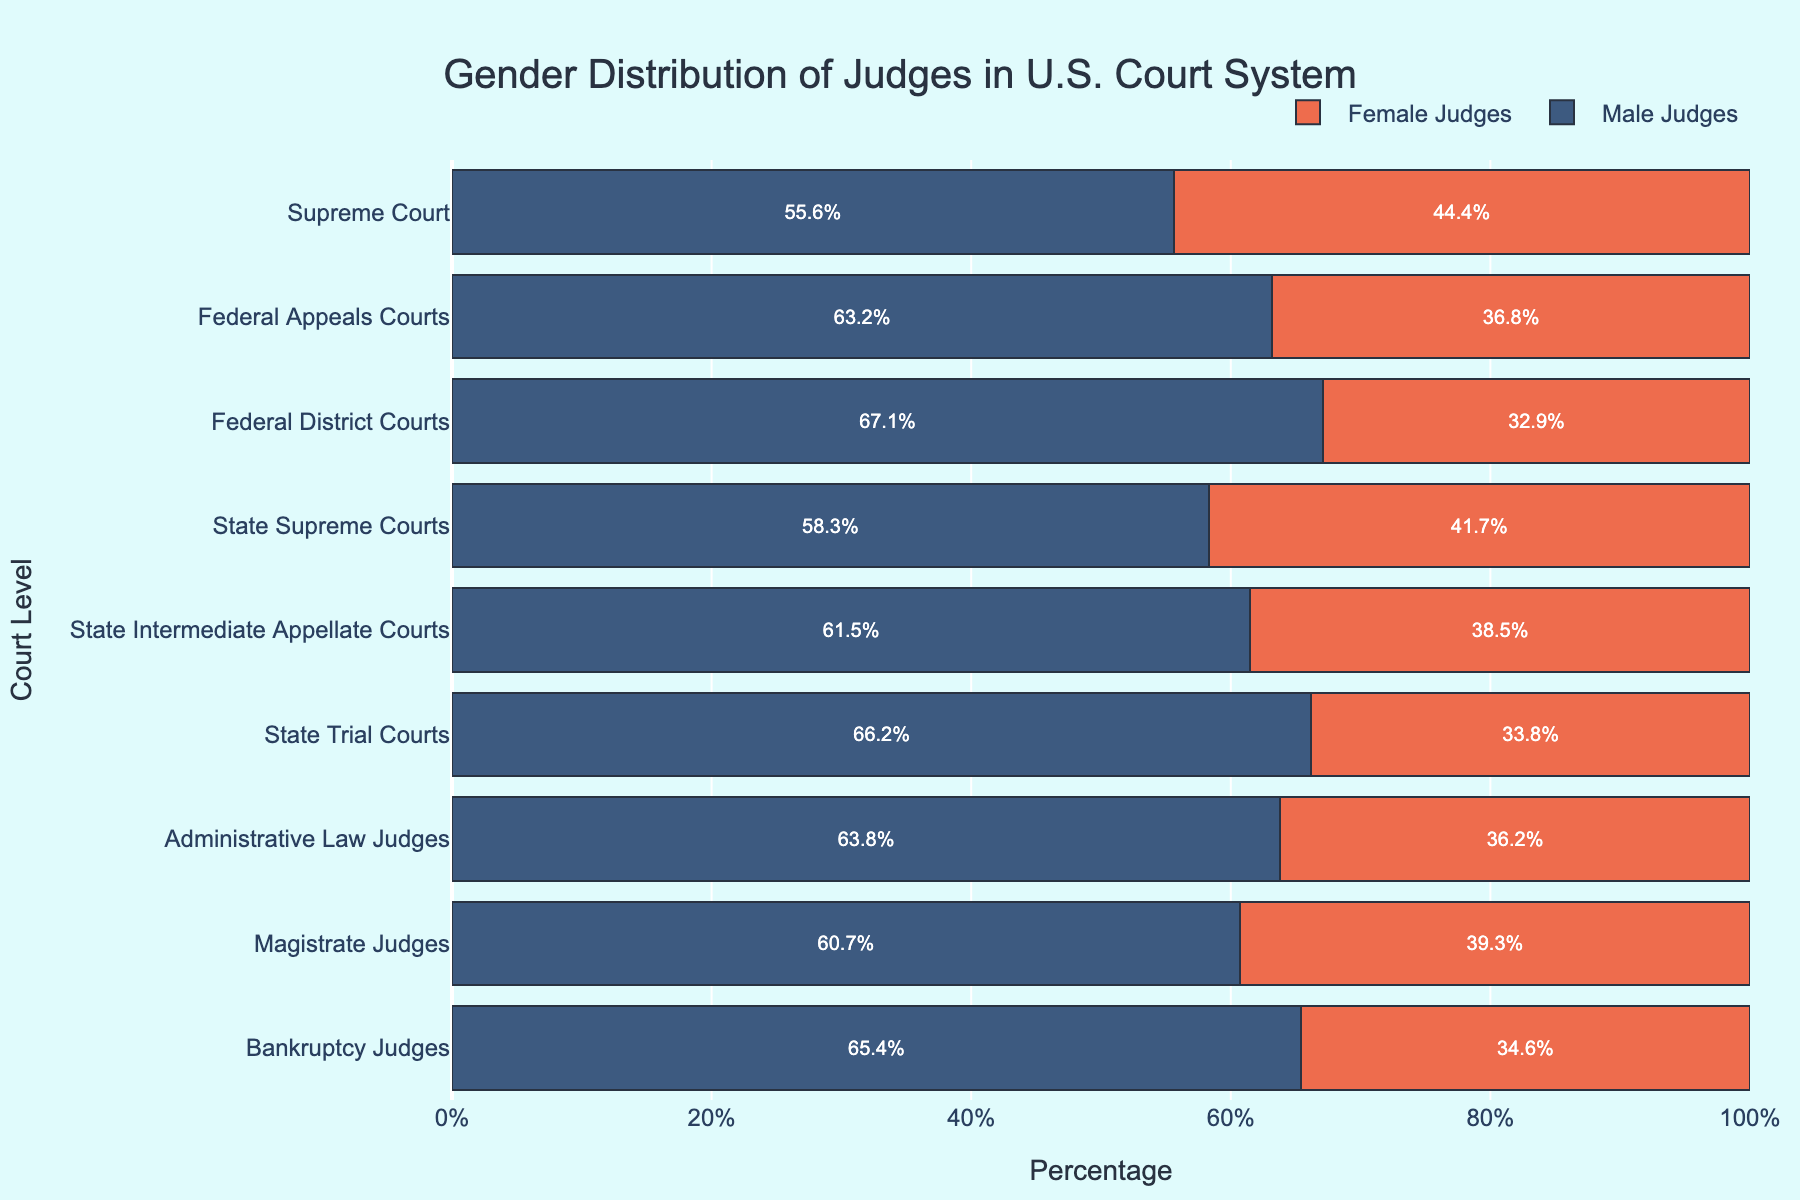What is the percentage of female judges in State Trial Courts? Locate the bar for State Trial Courts, then check the portion corresponding to female judges. It is marked with the percentage 33.8%.
Answer: 33.8% Which court level has the highest percentage of male judges? Compare the lengths of the blue bars (male judges) across all court levels. The Federal District Courts have the longest blue bar at 67.1%.
Answer: Federal District Courts What is the difference in the percentage of female judges between the Supreme Court and Federal Appeals Courts? Female Judges in the Supreme Court is 44.4%, and in Federal Appeals Courts is 36.8%. Subtract 36.8 from 44.4 which results in 7.6%.
Answer: 7.6% Which court level has nearly equal gender distribution, and what are the corresponding percentages? Analyze the bars for both genders to find where they are closest in length. The Supreme Court has nearly equal distribution with 55.6% male and 44.4% female judges.
Answer: Supreme Court, 55.6% male and 44.4% female What is the average percentage of female judges across all court levels? Add all percentages of female judges: 44.4 + 36.8 + 32.9 + 41.7 + 38.5 + 33.8 + 36.2 + 39.3 + 34.6 = 338.2. Divide by the number of court levels (9), which results in 37.6%.
Answer: 37.6% Which court levels have more than 60% male judges? Check the lengths of the male judges' bars and identify those above 60%. They are Federal Appeals Courts (63.2%), Federal District Courts (67.1%), State Intermediate Appellate Courts (61.5%), State Trial Courts (66.2%), Administrative Law Judges (63.8%), and Bankruptcy Judges (65.4%).
Answer: Federal Appeals Courts, Federal District Courts, State Intermediate Appellate Courts, State Trial Courts, Administrative Law Judges, Bankruptcy Judges 